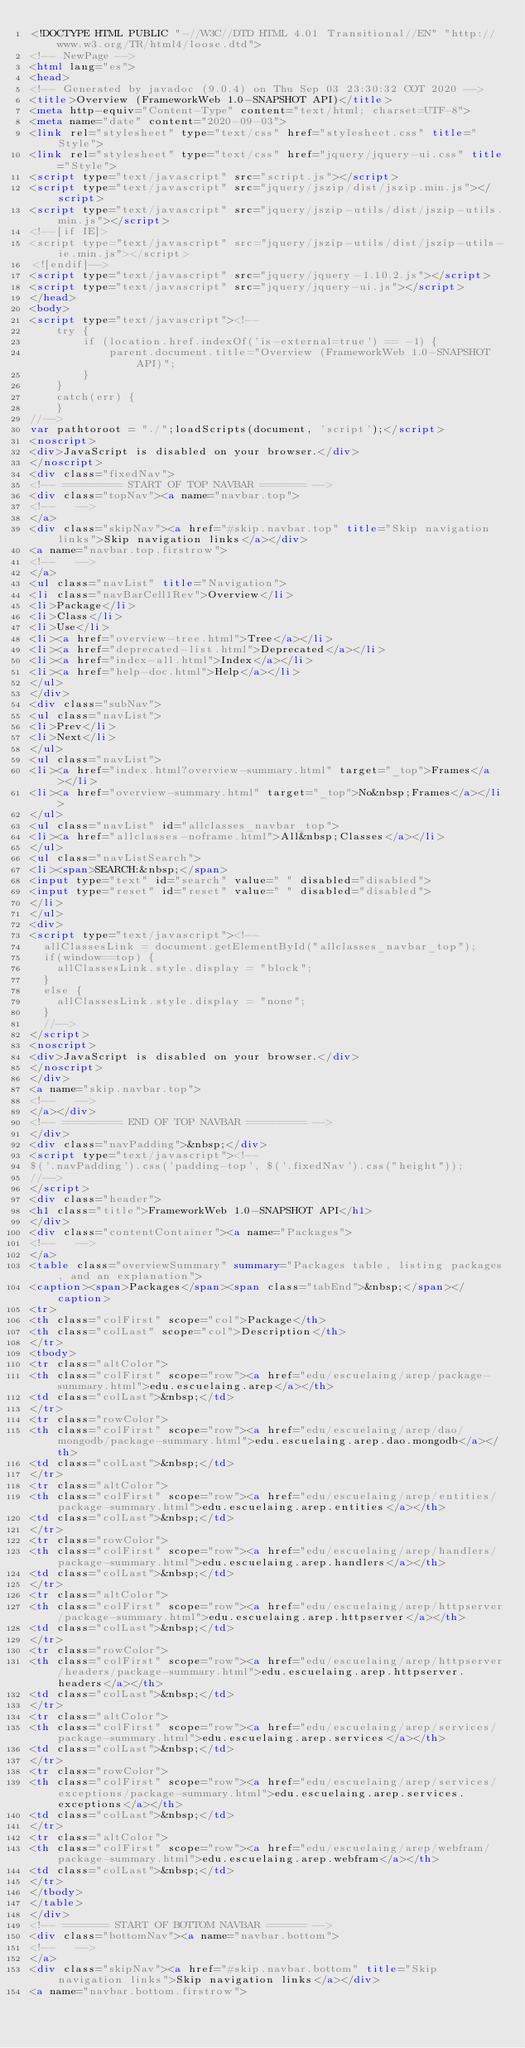Convert code to text. <code><loc_0><loc_0><loc_500><loc_500><_HTML_><!DOCTYPE HTML PUBLIC "-//W3C//DTD HTML 4.01 Transitional//EN" "http://www.w3.org/TR/html4/loose.dtd">
<!-- NewPage -->
<html lang="es">
<head>
<!-- Generated by javadoc (9.0.4) on Thu Sep 03 23:30:32 COT 2020 -->
<title>Overview (FrameworkWeb 1.0-SNAPSHOT API)</title>
<meta http-equiv="Content-Type" content="text/html; charset=UTF-8">
<meta name="date" content="2020-09-03">
<link rel="stylesheet" type="text/css" href="stylesheet.css" title="Style">
<link rel="stylesheet" type="text/css" href="jquery/jquery-ui.css" title="Style">
<script type="text/javascript" src="script.js"></script>
<script type="text/javascript" src="jquery/jszip/dist/jszip.min.js"></script>
<script type="text/javascript" src="jquery/jszip-utils/dist/jszip-utils.min.js"></script>
<!--[if IE]>
<script type="text/javascript" src="jquery/jszip-utils/dist/jszip-utils-ie.min.js"></script>
<![endif]-->
<script type="text/javascript" src="jquery/jquery-1.10.2.js"></script>
<script type="text/javascript" src="jquery/jquery-ui.js"></script>
</head>
<body>
<script type="text/javascript"><!--
    try {
        if (location.href.indexOf('is-external=true') == -1) {
            parent.document.title="Overview (FrameworkWeb 1.0-SNAPSHOT API)";
        }
    }
    catch(err) {
    }
//-->
var pathtoroot = "./";loadScripts(document, 'script');</script>
<noscript>
<div>JavaScript is disabled on your browser.</div>
</noscript>
<div class="fixedNav">
<!-- ========= START OF TOP NAVBAR ======= -->
<div class="topNav"><a name="navbar.top">
<!--   -->
</a>
<div class="skipNav"><a href="#skip.navbar.top" title="Skip navigation links">Skip navigation links</a></div>
<a name="navbar.top.firstrow">
<!--   -->
</a>
<ul class="navList" title="Navigation">
<li class="navBarCell1Rev">Overview</li>
<li>Package</li>
<li>Class</li>
<li>Use</li>
<li><a href="overview-tree.html">Tree</a></li>
<li><a href="deprecated-list.html">Deprecated</a></li>
<li><a href="index-all.html">Index</a></li>
<li><a href="help-doc.html">Help</a></li>
</ul>
</div>
<div class="subNav">
<ul class="navList">
<li>Prev</li>
<li>Next</li>
</ul>
<ul class="navList">
<li><a href="index.html?overview-summary.html" target="_top">Frames</a></li>
<li><a href="overview-summary.html" target="_top">No&nbsp;Frames</a></li>
</ul>
<ul class="navList" id="allclasses_navbar_top">
<li><a href="allclasses-noframe.html">All&nbsp;Classes</a></li>
</ul>
<ul class="navListSearch">
<li><span>SEARCH:&nbsp;</span>
<input type="text" id="search" value=" " disabled="disabled">
<input type="reset" id="reset" value=" " disabled="disabled">
</li>
</ul>
<div>
<script type="text/javascript"><!--
  allClassesLink = document.getElementById("allclasses_navbar_top");
  if(window==top) {
    allClassesLink.style.display = "block";
  }
  else {
    allClassesLink.style.display = "none";
  }
  //-->
</script>
<noscript>
<div>JavaScript is disabled on your browser.</div>
</noscript>
</div>
<a name="skip.navbar.top">
<!--   -->
</a></div>
<!-- ========= END OF TOP NAVBAR ========= -->
</div>
<div class="navPadding">&nbsp;</div>
<script type="text/javascript"><!--
$('.navPadding').css('padding-top', $('.fixedNav').css("height"));
//-->
</script>
<div class="header">
<h1 class="title">FrameworkWeb 1.0-SNAPSHOT API</h1>
</div>
<div class="contentContainer"><a name="Packages">
<!--   -->
</a>
<table class="overviewSummary" summary="Packages table, listing packages, and an explanation">
<caption><span>Packages</span><span class="tabEnd">&nbsp;</span></caption>
<tr>
<th class="colFirst" scope="col">Package</th>
<th class="colLast" scope="col">Description</th>
</tr>
<tbody>
<tr class="altColor">
<th class="colFirst" scope="row"><a href="edu/escuelaing/arep/package-summary.html">edu.escuelaing.arep</a></th>
<td class="colLast">&nbsp;</td>
</tr>
<tr class="rowColor">
<th class="colFirst" scope="row"><a href="edu/escuelaing/arep/dao/mongodb/package-summary.html">edu.escuelaing.arep.dao.mongodb</a></th>
<td class="colLast">&nbsp;</td>
</tr>
<tr class="altColor">
<th class="colFirst" scope="row"><a href="edu/escuelaing/arep/entities/package-summary.html">edu.escuelaing.arep.entities</a></th>
<td class="colLast">&nbsp;</td>
</tr>
<tr class="rowColor">
<th class="colFirst" scope="row"><a href="edu/escuelaing/arep/handlers/package-summary.html">edu.escuelaing.arep.handlers</a></th>
<td class="colLast">&nbsp;</td>
</tr>
<tr class="altColor">
<th class="colFirst" scope="row"><a href="edu/escuelaing/arep/httpserver/package-summary.html">edu.escuelaing.arep.httpserver</a></th>
<td class="colLast">&nbsp;</td>
</tr>
<tr class="rowColor">
<th class="colFirst" scope="row"><a href="edu/escuelaing/arep/httpserver/headers/package-summary.html">edu.escuelaing.arep.httpserver.headers</a></th>
<td class="colLast">&nbsp;</td>
</tr>
<tr class="altColor">
<th class="colFirst" scope="row"><a href="edu/escuelaing/arep/services/package-summary.html">edu.escuelaing.arep.services</a></th>
<td class="colLast">&nbsp;</td>
</tr>
<tr class="rowColor">
<th class="colFirst" scope="row"><a href="edu/escuelaing/arep/services/exceptions/package-summary.html">edu.escuelaing.arep.services.exceptions</a></th>
<td class="colLast">&nbsp;</td>
</tr>
<tr class="altColor">
<th class="colFirst" scope="row"><a href="edu/escuelaing/arep/webfram/package-summary.html">edu.escuelaing.arep.webfram</a></th>
<td class="colLast">&nbsp;</td>
</tr>
</tbody>
</table>
</div>
<!-- ======= START OF BOTTOM NAVBAR ====== -->
<div class="bottomNav"><a name="navbar.bottom">
<!--   -->
</a>
<div class="skipNav"><a href="#skip.navbar.bottom" title="Skip navigation links">Skip navigation links</a></div>
<a name="navbar.bottom.firstrow"></code> 